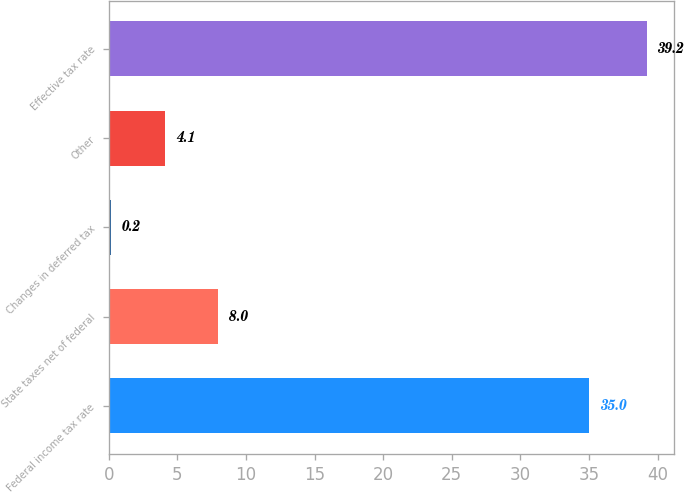Convert chart. <chart><loc_0><loc_0><loc_500><loc_500><bar_chart><fcel>Federal income tax rate<fcel>State taxes net of federal<fcel>Changes in deferred tax<fcel>Other<fcel>Effective tax rate<nl><fcel>35<fcel>8<fcel>0.2<fcel>4.1<fcel>39.2<nl></chart> 